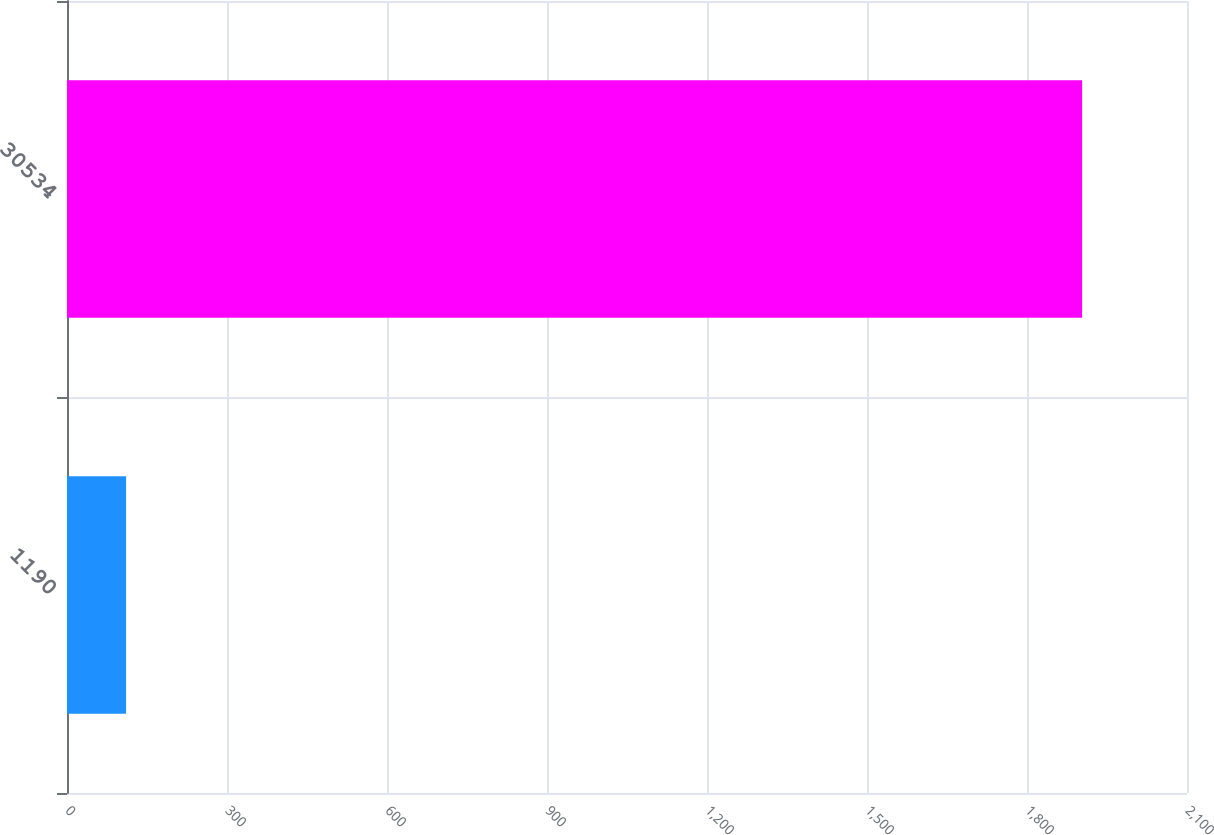Convert chart. <chart><loc_0><loc_0><loc_500><loc_500><bar_chart><fcel>1190<fcel>30534<nl><fcel>110.8<fcel>1903.3<nl></chart> 